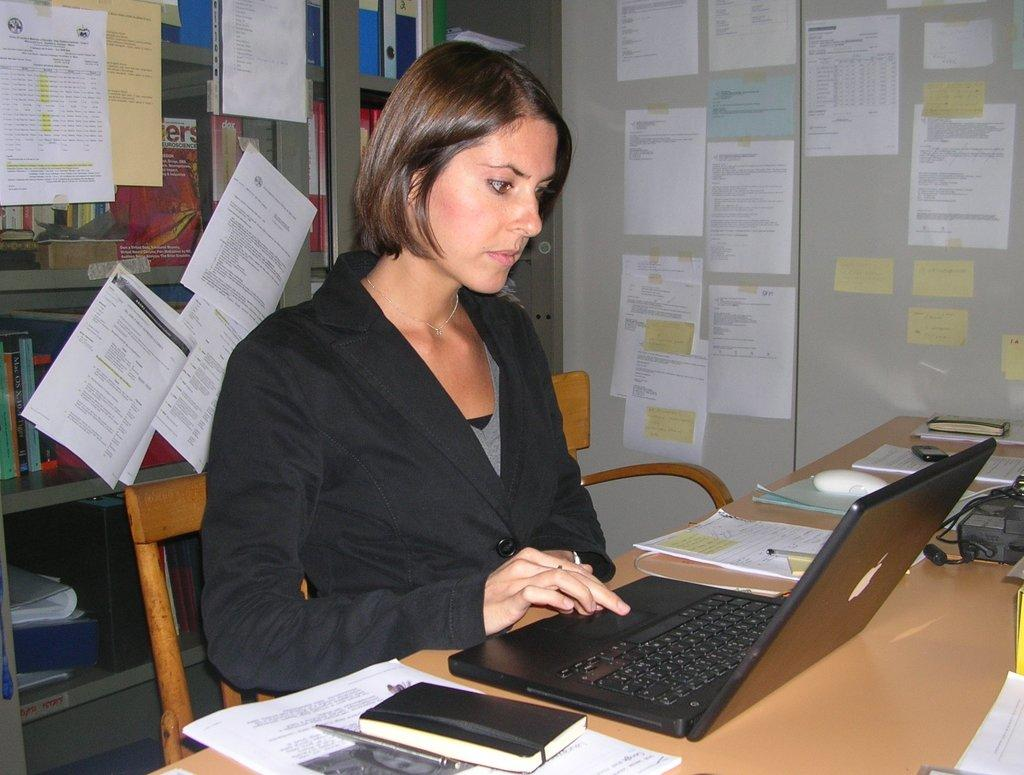<image>
Give a short and clear explanation of the subsequent image. A woman uses a laptop in front of books, one of which says Mac OS X. 